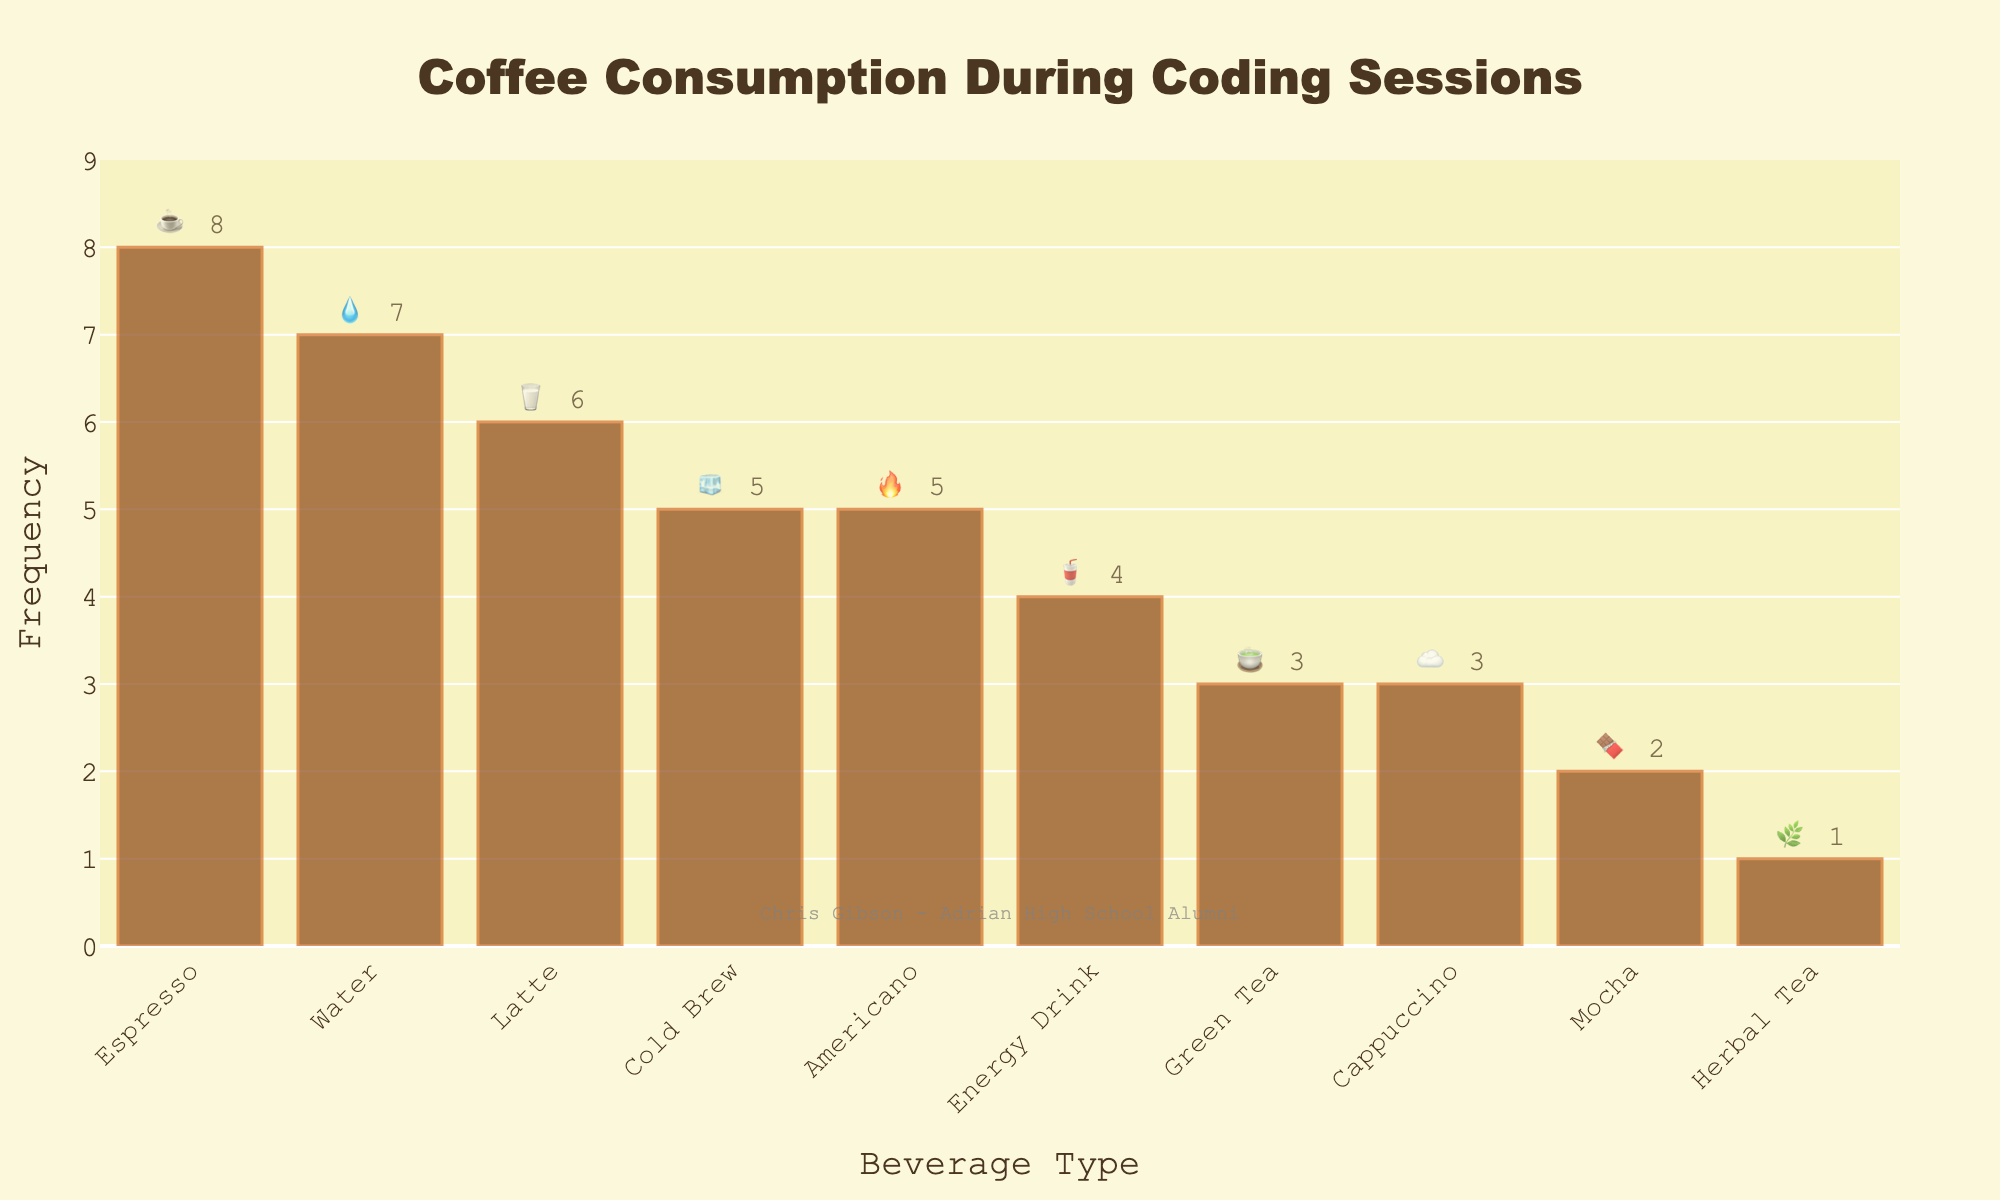What is the most frequently consumed beverage during coding sessions? The bar with the highest frequency shows the most consumed beverage. From the chart, Espresso has the highest bar indicating it is the most frequently consumed beverage.
Answer: Espresso ☕ What is the least consumed beverage during coding sessions? The bar with the lowest frequency indicates the least consumed beverage. The chart shows Herbal Tea has the smallest bar.
Answer: Herbal Tea 🌿 How many types of beverages are more frequently consumed than Green Tea during coding sessions? Identify bars with frequencies higher than Green Tea's frequency (3). Espresso, Latte, Cold Brew, Energy Drink, Water, and Americano have higher frequencies, totaling 6.
Answer: 6 Which beverage has a frequency of 5? The bar with a frequency of 5 corresponds to two beverages. Checking the labels, Cold Brew and Americano both have a frequency of 5.
Answer: Cold Brew 🧊 and Americano 🔥 What is the total frequency of consumption for all tea varieties (Green Tea and Herbal Tea)? Sum the frequencies of Green Tea and Herbal Tea. Green Tea has a frequency of 3, and Herbal Tea has a frequency of 1. Their total is 3 + 1.
Answer: 4 How many more times is Espresso consumed compared to Mocha? Subtract Mocha's frequency from Espresso's frequency. Espresso has a frequency of 8, and Mocha has 2. The difference is 8 - 2.
Answer: 6 How many more times is Water consumed compared to Herbal Tea? Subtract Herbal Tea's frequency from Water's frequency. Water has a frequency of 7, and Herbal Tea has 1. The difference is 7 - 1.
Answer: 6 What is the combined frequency of Latte and Cappuccino? Add the frequencies of Latte and Cappuccino. Latte has a frequency of 6, and Cappuccino has 3. Their total is 6 + 3.
Answer: 9 Which beverage has the fire emoji and what is its consumption frequency? Look for the beverage associated with the fire emoji and its frequency. Americano has the fire emoji with a frequency of 5.
Answer: Americano 🔥 How many beverages have a frequency of exactly 3? Count the number of bars with a frequency of 3. From the chart, Green Tea and Cappuccino each have a frequency of 3.
Answer: 2 